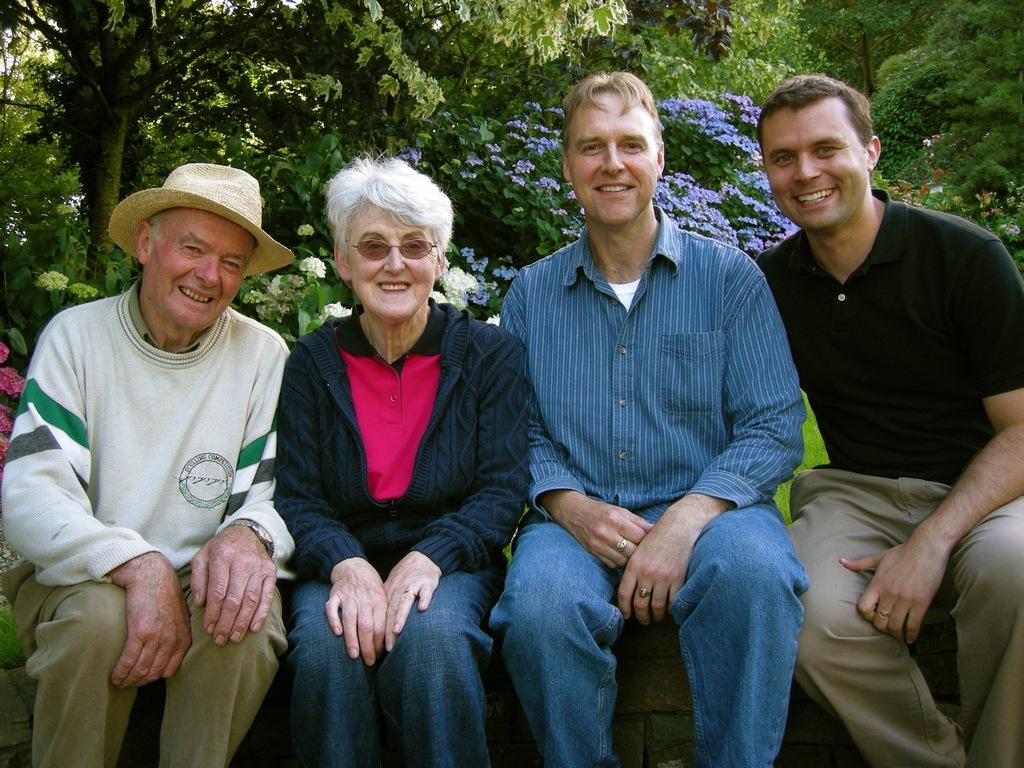Who is present in the image? There are people in the image. What expression do the people have? The people are smiling. What can be seen in the background of the image? There are trees and plants with flowers in the background of the image. Can you describe the clothing of one of the people in the image? There is a man wearing a hat in the image. What type of worm can be seen crawling on the man's trousers in the image? There is no worm present in the image, and the man's trousers are not mentioned. Who is taking the picture of the people in the image? There is no camera or photographer present in the image, so it cannot be determined who is taking the picture. 